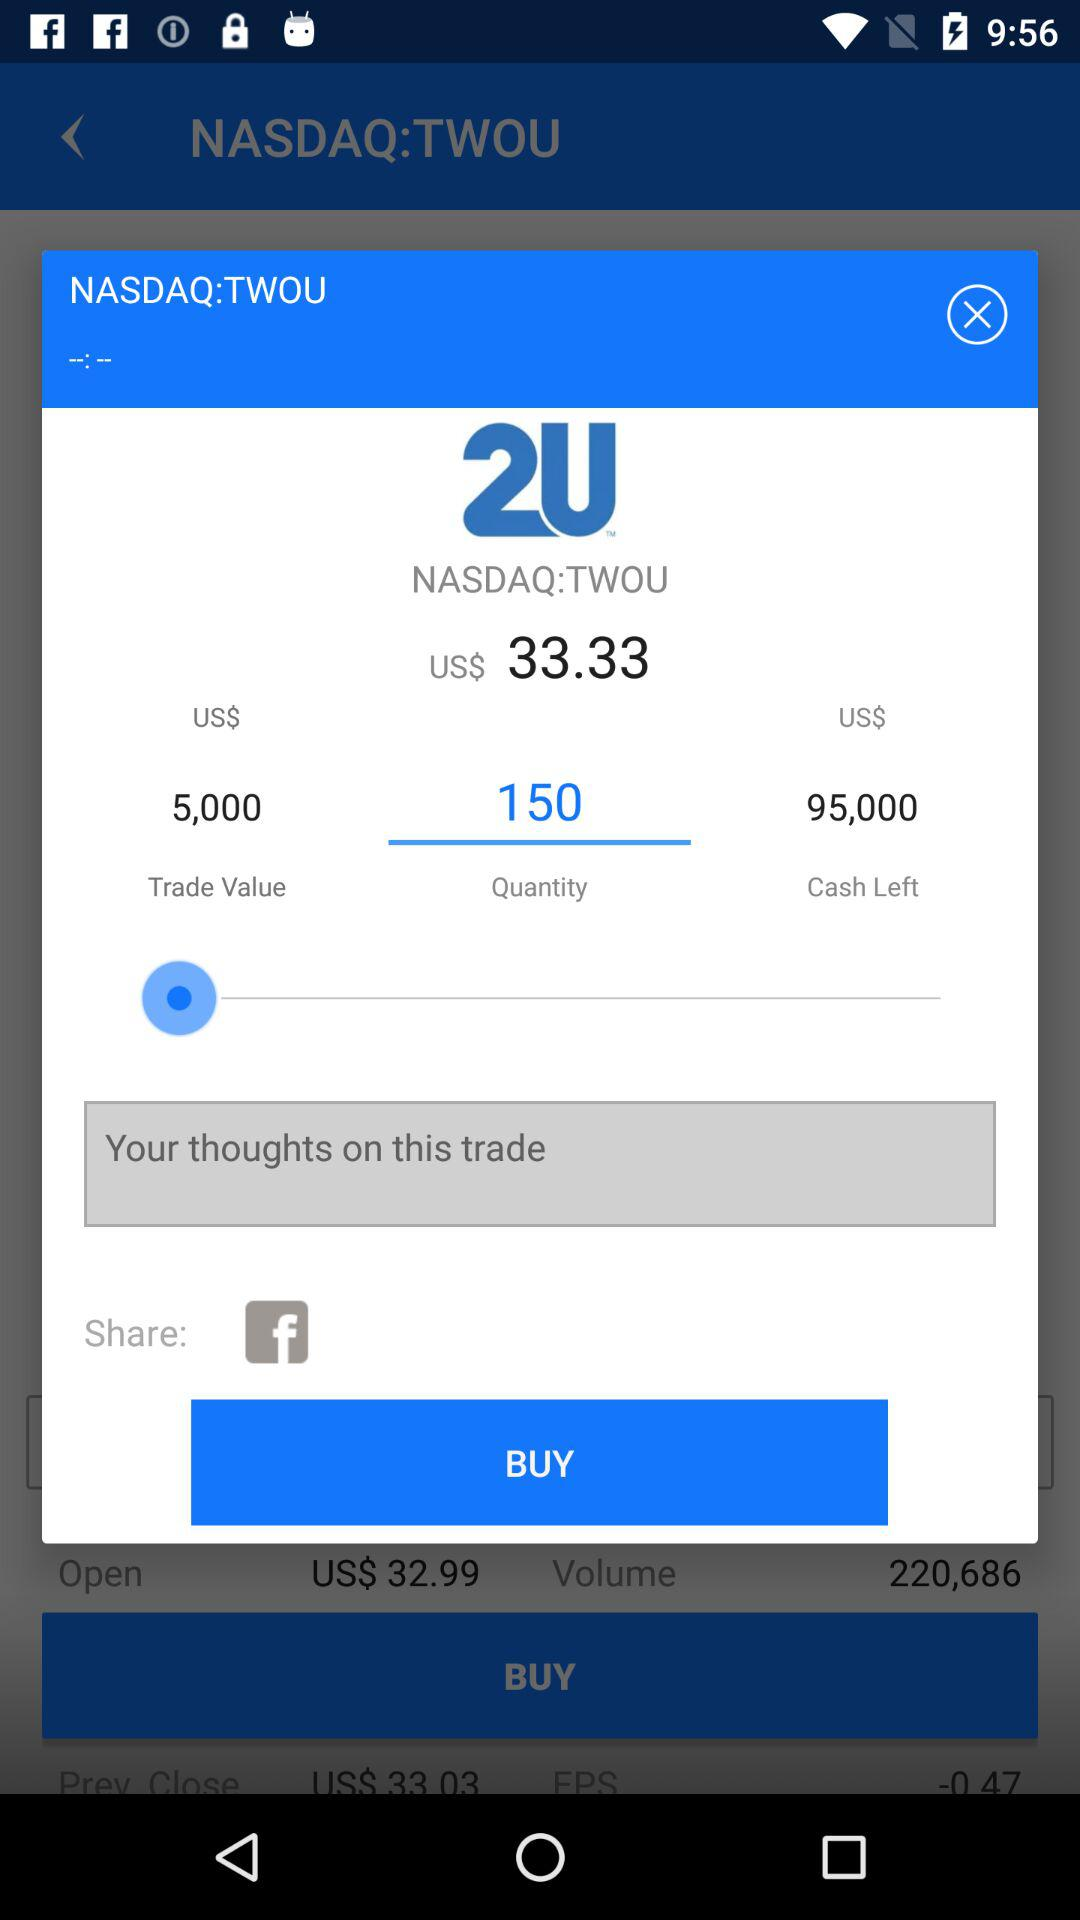How much cash is left? The cash left is 95,000 USD. 